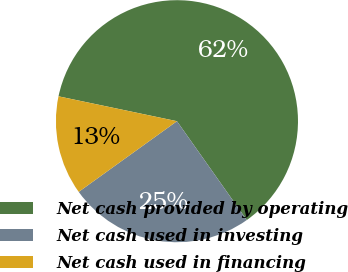Convert chart. <chart><loc_0><loc_0><loc_500><loc_500><pie_chart><fcel>Net cash provided by operating<fcel>Net cash used in investing<fcel>Net cash used in financing<nl><fcel>61.92%<fcel>24.86%<fcel>13.22%<nl></chart> 